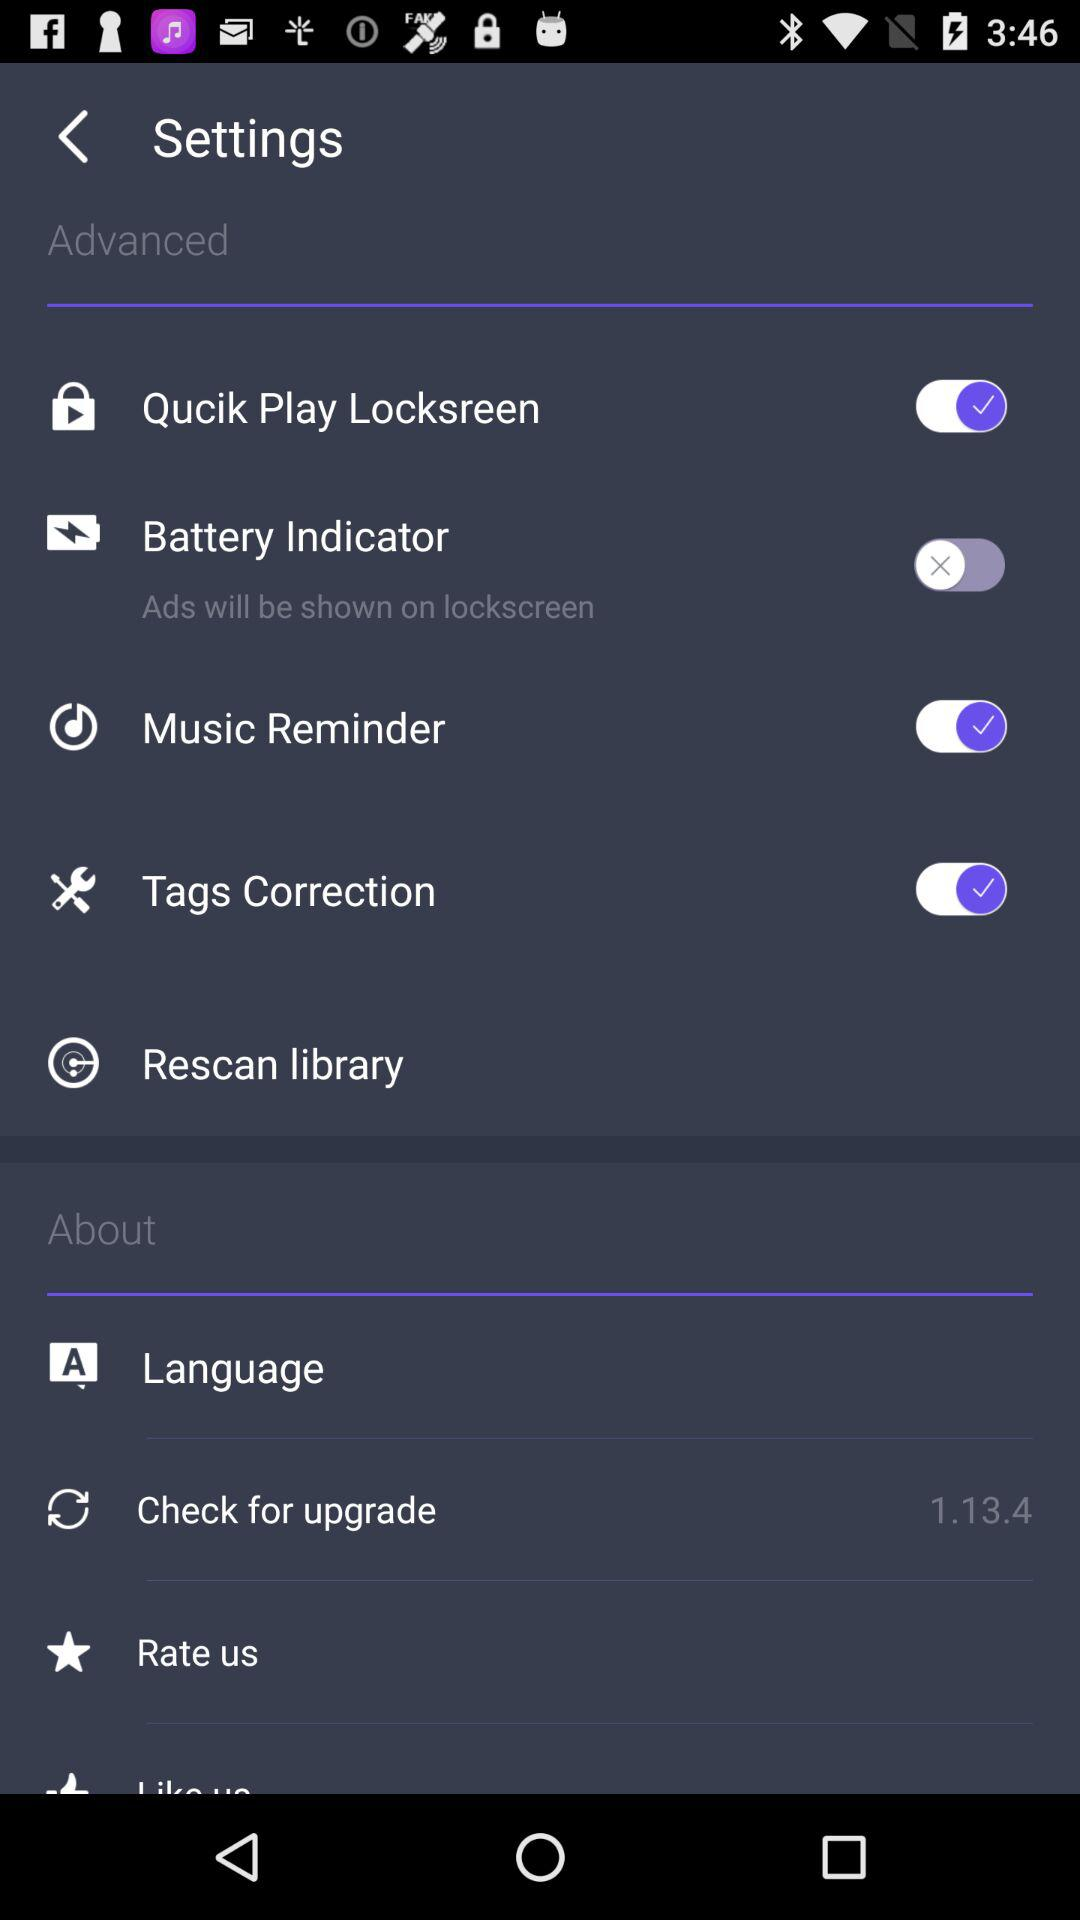What is the version of the application? The version is 1.13.4. 